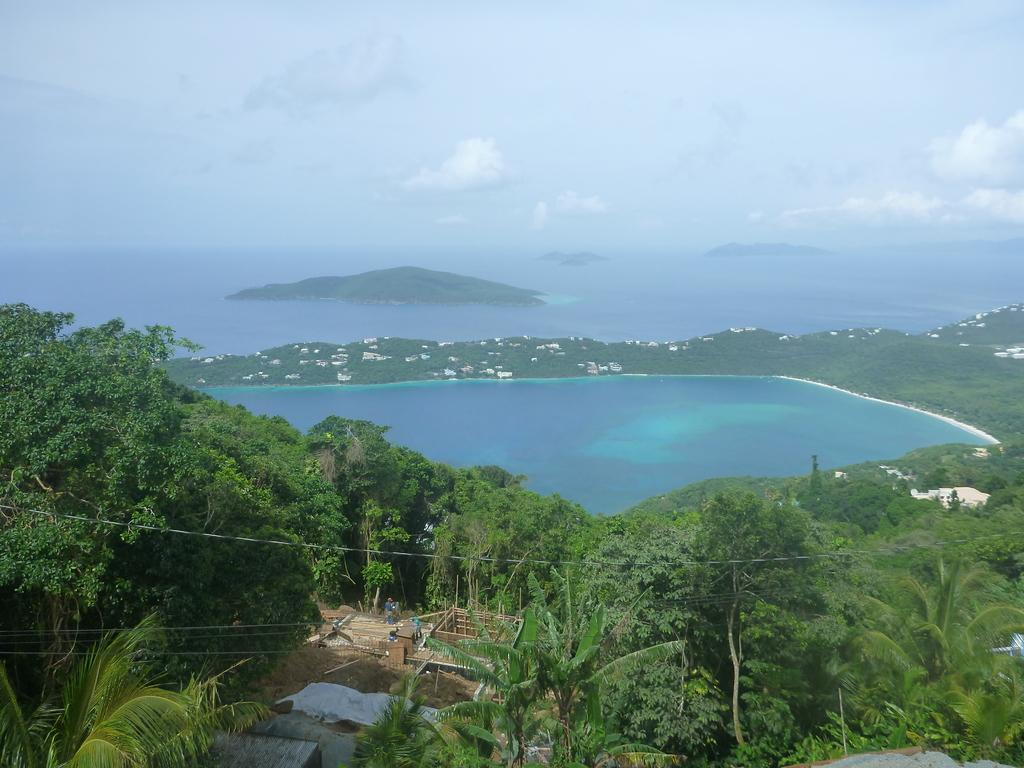What type of vegetation is present at the bottom of the image? There are trees at the bottom of the image. What can be seen in the middle of the image? There is water in the middle of the image. What is visible at the top of the image? The sky is visible at the top of the image. How many pizzas are floating on the water in the image? There are no pizzas present in the image; it features trees, water, and the sky. What type of cloth is draped over the trees in the image? There is no cloth draped over the trees in the image; only trees, water, and the sky are present. 